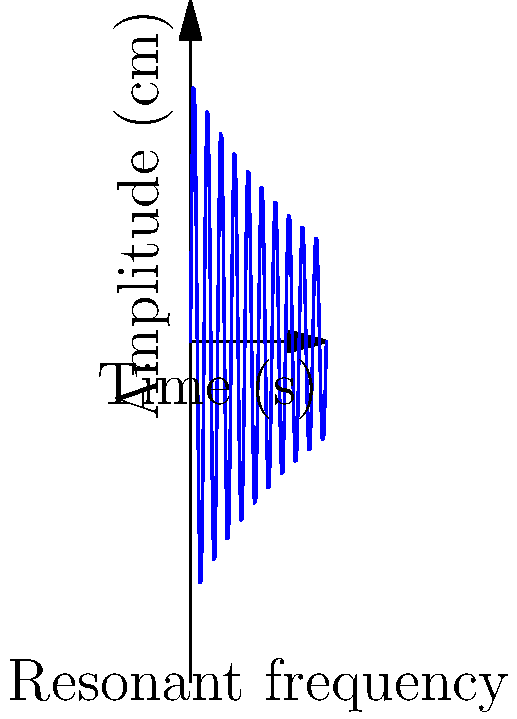A crystal chandelier in your Victorian house exhibits oscillations when excited by sound waves. The graph shows the chandelier's response to a sound pulse over time. If the chandelier's natural frequency is 2 Hz, what is its resonant angular frequency in radians per second? To find the resonant angular frequency, we'll follow these steps:

1) The natural frequency of the chandelier is given as 2 Hz. This is the frequency at which the chandelier naturally oscillates.

2) The relationship between frequency (f) and angular frequency (ω) is:

   $$\omega = 2\pi f$$

3) We can substitute the given frequency into this equation:

   $$\omega = 2\pi (2\text{ Hz})$$

4) Now, let's calculate:

   $$\omega = 4\pi \text{ rad/s}$$

5) This can be simplified to:

   $$\omega = 12.57 \text{ rad/s}$$

The resonant angular frequency of the chandelier is approximately 12.57 rad/s.
Answer: $12.57 \text{ rad/s}$ 